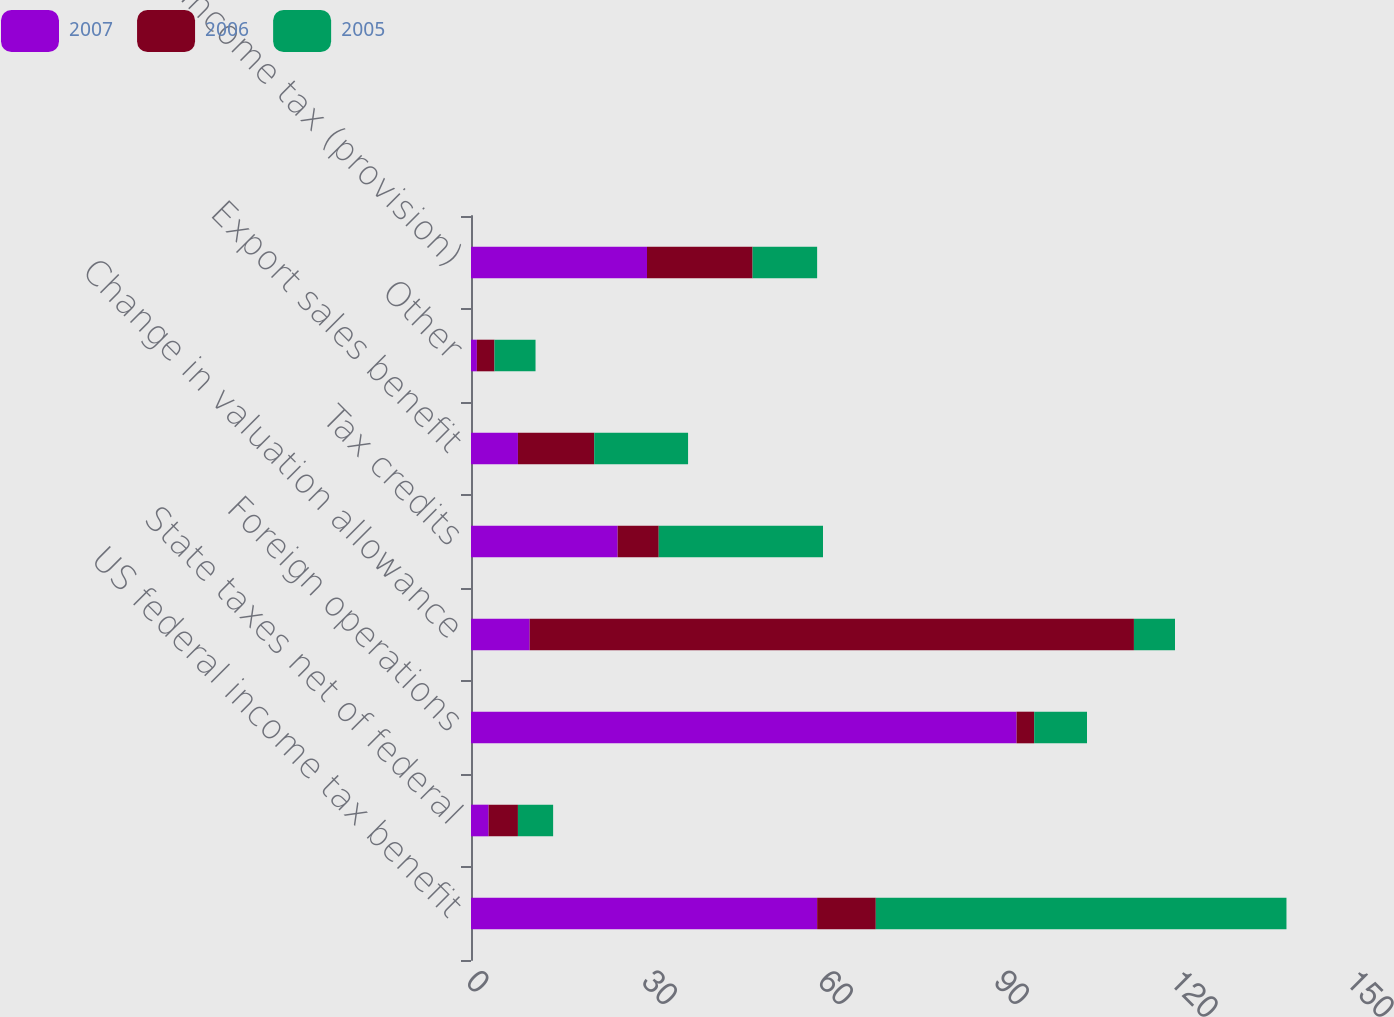<chart> <loc_0><loc_0><loc_500><loc_500><stacked_bar_chart><ecel><fcel>US federal income tax benefit<fcel>State taxes net of federal<fcel>Foreign operations<fcel>Change in valuation allowance<fcel>Tax credits<fcel>Export sales benefit<fcel>Other<fcel>Income tax (provision)<nl><fcel>2007<fcel>59<fcel>3<fcel>93<fcel>10<fcel>25<fcel>8<fcel>1<fcel>30<nl><fcel>2006<fcel>10<fcel>5<fcel>3<fcel>103<fcel>7<fcel>13<fcel>3<fcel>18<nl><fcel>2005<fcel>70<fcel>6<fcel>9<fcel>7<fcel>28<fcel>16<fcel>7<fcel>11<nl></chart> 